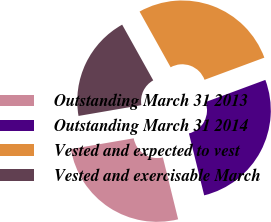Convert chart. <chart><loc_0><loc_0><loc_500><loc_500><pie_chart><fcel>Outstanding March 31 2013<fcel>Outstanding March 31 2014<fcel>Vested and expected to vest<fcel>Vested and exercisable March<nl><fcel>26.14%<fcel>26.8%<fcel>27.45%<fcel>19.61%<nl></chart> 